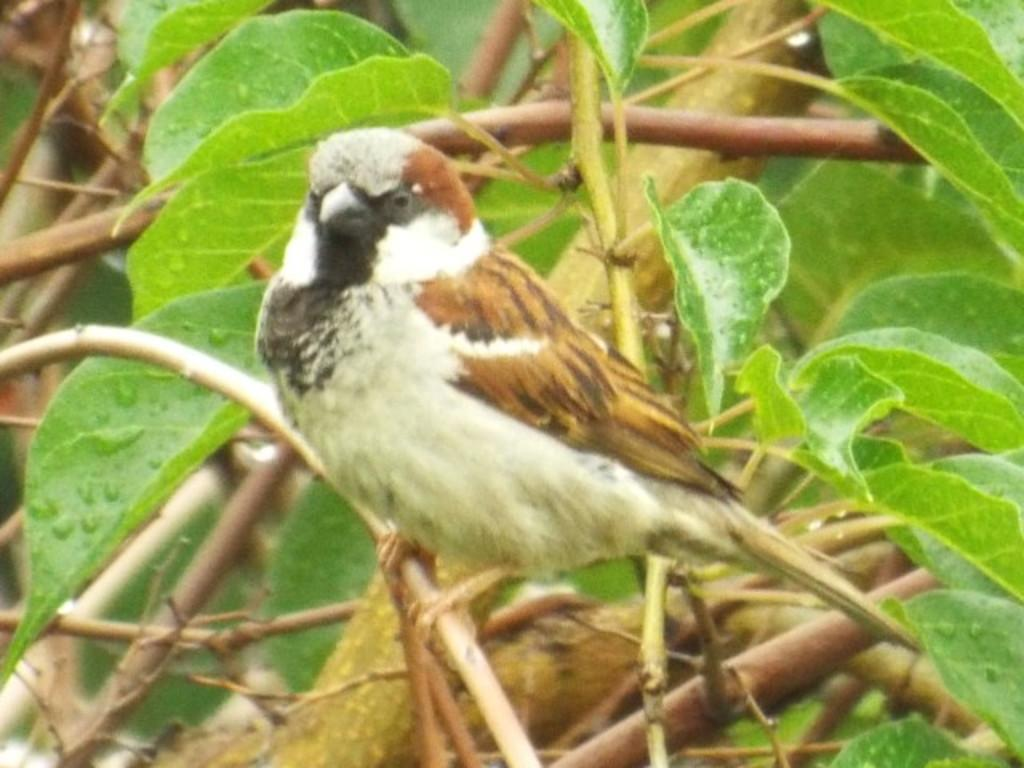What is the main subject in the center of the image? There is a tree in the center of the image. What is on the tree in the image? There is a bird on the branch of the tree. Can you describe the bird's appearance? The bird has a brown and white color. What type of oatmeal is being served in the jar at the station in the image? There is no jar, oatmeal, or station present in the image; it features a tree with a bird on its branch. 